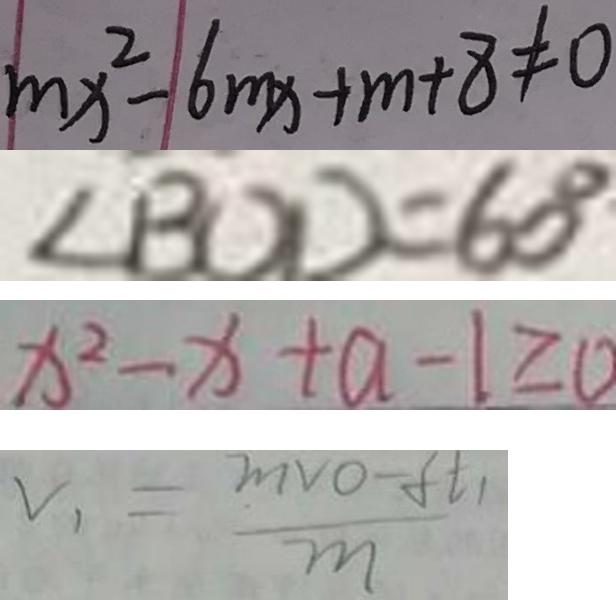<formula> <loc_0><loc_0><loc_500><loc_500>m x ^ { 2 } - 6 m x + m + 8 \neq 0 
 \angle B O D = 6 0 ^ { \circ } 
 x ^ { 2 } - x + a - 1 \geq 0 
 v _ { 1 } = \frac { m V O - f t _ { 1 } } { m }</formula> 